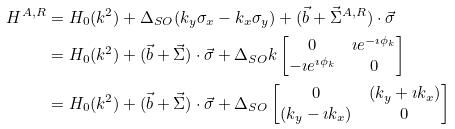Convert formula to latex. <formula><loc_0><loc_0><loc_500><loc_500>H ^ { A , R } & = H _ { 0 } ( k ^ { 2 } ) + \Delta _ { S O } ( k _ { y } \sigma _ { x } - k _ { x } \sigma _ { y } ) + ( \vec { b } + \vec { \Sigma } ^ { A , R } ) \cdot \vec { \sigma } \\ & = H _ { 0 } ( k ^ { 2 } ) + ( \vec { b } + \vec { \Sigma } ) \cdot \vec { \sigma } + \Delta _ { S O } k \begin{bmatrix} 0 & \imath e ^ { - \imath \phi _ { k } } \\ - \imath e ^ { \imath \phi _ { k } } & 0 \end{bmatrix} \\ & = H _ { 0 } ( k ^ { 2 } ) + ( \vec { b } + \vec { \Sigma } ) \cdot \vec { \sigma } + \Delta _ { S O } \begin{bmatrix} 0 & ( k _ { y } + \imath k _ { x } ) \\ ( k _ { y } - \imath k _ { x } ) & 0 \end{bmatrix} \\</formula> 